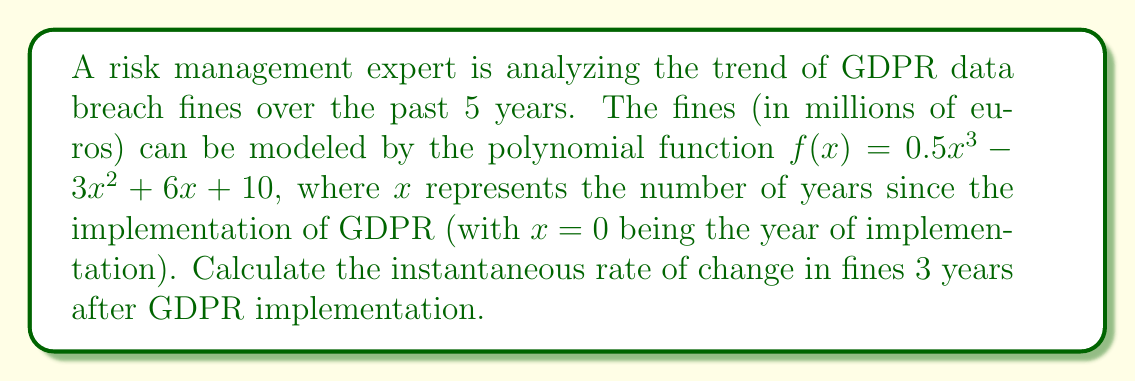Solve this math problem. To find the instantaneous rate of change at a specific point, we need to calculate the derivative of the function and evaluate it at the given point.

1. The given function is:
   $f(x) = 0.5x^3 - 3x^2 + 6x + 10$

2. Calculate the derivative $f'(x)$:
   $f'(x) = \frac{d}{dx}(0.5x^3 - 3x^2 + 6x + 10)$
   $f'(x) = 1.5x^2 - 6x + 6$

3. We need to find the rate of change 3 years after implementation, so we evaluate $f'(x)$ at $x = 3$:
   $f'(3) = 1.5(3)^2 - 6(3) + 6$
   $f'(3) = 1.5(9) - 18 + 6$
   $f'(3) = 13.5 - 18 + 6$
   $f'(3) = 1.5$

The instantaneous rate of change is 1.5 million euros per year, 3 years after GDPR implementation.
Answer: 1.5 million euros per year 